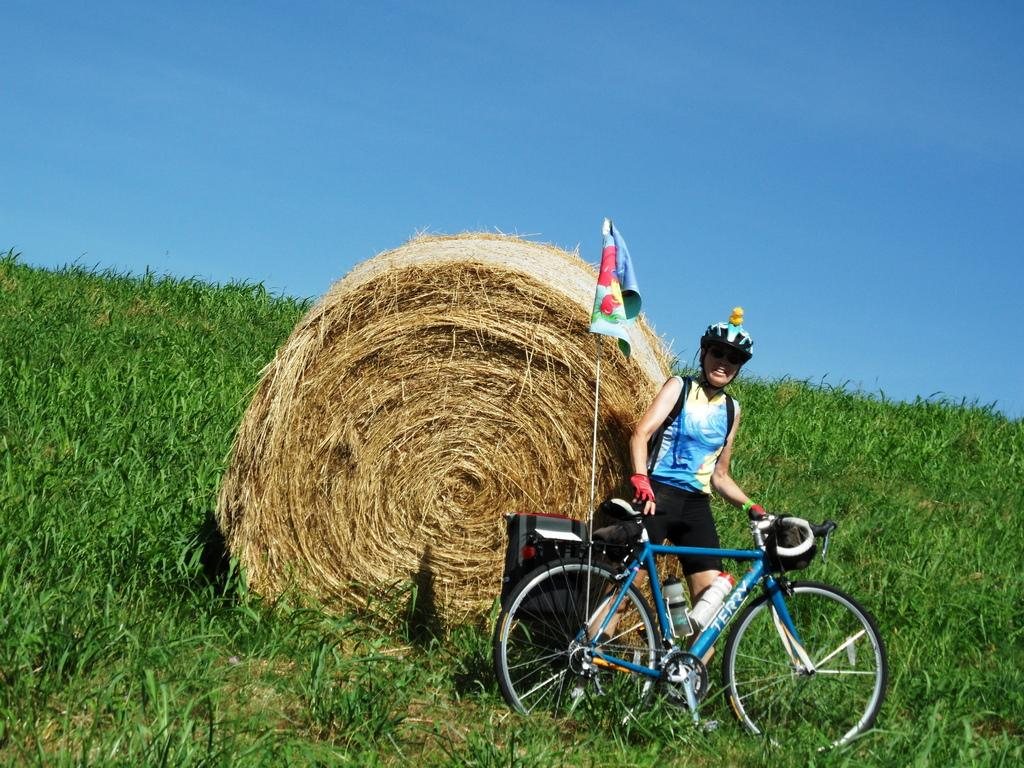What type of vegetation is present in the image? There is grass in the image. What object can be seen in the image besides the grass? There is a flag in the image. What is the woman in the image wearing? The woman is wearing a helmet in the image. What is the woman holding in the image? The woman is holding a bicycle in the image. What is visible at the top of the image? The sky is visible at the top of the image. Where is the book located in the image? There is no book present in the image. What type of bath can be seen in the image? There is no bath present in the image. 